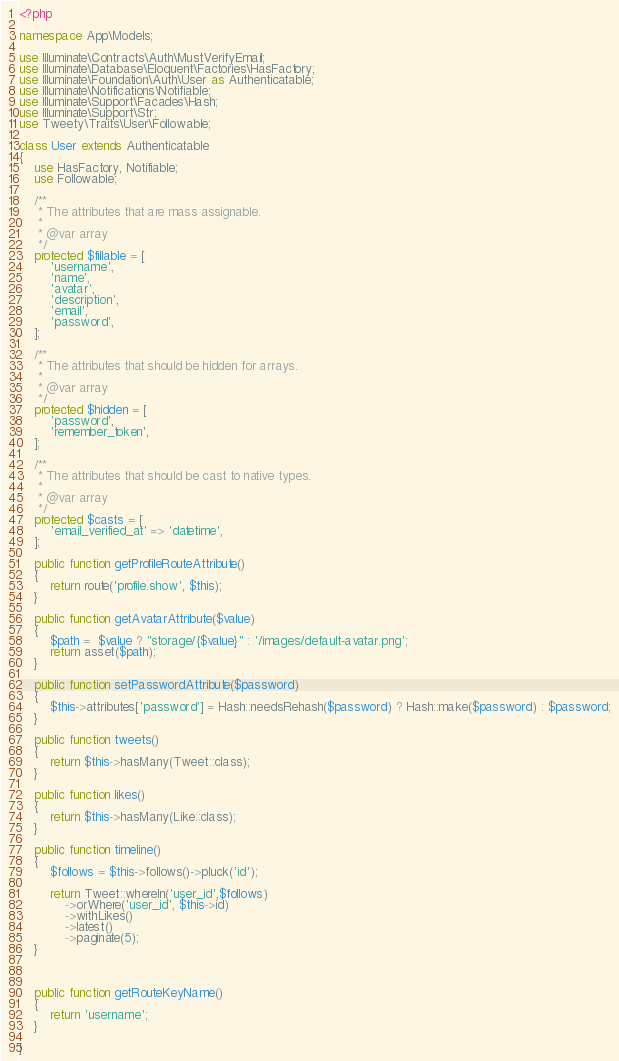Convert code to text. <code><loc_0><loc_0><loc_500><loc_500><_PHP_><?php

namespace App\Models;

use Illuminate\Contracts\Auth\MustVerifyEmail;
use Illuminate\Database\Eloquent\Factories\HasFactory;
use Illuminate\Foundation\Auth\User as Authenticatable;
use Illuminate\Notifications\Notifiable;
use Illuminate\Support\Facades\Hash;
use Illuminate\Support\Str;
use Tweety\Traits\User\Followable;

class User extends Authenticatable
{
    use HasFactory, Notifiable;
    use Followable;

    /**
     * The attributes that are mass assignable.
     *
     * @var array
     */
    protected $fillable = [
        'username',
        'name',
        'avatar',
        'description',
        'email',
        'password',
    ];

    /**
     * The attributes that should be hidden for arrays.
     *
     * @var array
     */
    protected $hidden = [
        'password',
        'remember_token',
    ];

    /**
     * The attributes that should be cast to native types.
     *
     * @var array
     */
    protected $casts = [
        'email_verified_at' => 'datetime',
    ];

    public function getProfileRouteAttribute()
    {
        return route('profile.show', $this);
    }

    public function getAvatarAttribute($value)
    {
        $path =  $value ? "storage/{$value}" : '/images/default-avatar.png';
        return asset($path);
    }

    public function setPasswordAttribute($password)
    {
        $this->attributes['password'] = Hash::needsRehash($password) ? Hash::make($password) : $password;
    }

    public function tweets()
    {
        return $this->hasMany(Tweet::class);
    }

    public function likes()
    {
        return $this->hasMany(Like::class);
    }

    public function timeline()
    {
        $follows = $this->follows()->pluck('id');

        return Tweet::whereIn('user_id',$follows)
            ->orWhere('user_id', $this->id)
            ->withLikes()
            ->latest()
            ->paginate(5);
    }



    public function getRouteKeyName()
    {
        return 'username';
    }

}
</code> 